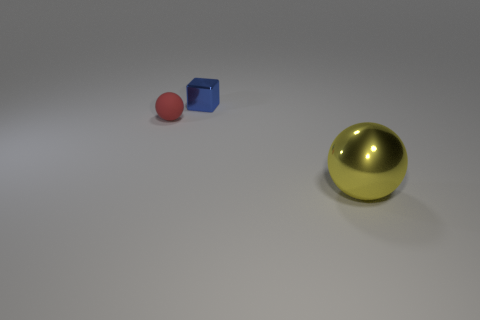Are there the same number of yellow spheres on the left side of the big object and blue metallic cubes?
Your answer should be compact. No. What number of spheres are both right of the tiny blue shiny object and to the left of the blue object?
Keep it short and to the point. 0. What is the size of the yellow sphere that is made of the same material as the blue cube?
Keep it short and to the point. Large. How many blue metal things have the same shape as the tiny red thing?
Your answer should be very brief. 0. Are there more metallic things that are in front of the matte sphere than big cyan blocks?
Make the answer very short. Yes. There is a object that is both on the right side of the red rubber thing and in front of the small metal block; what shape is it?
Offer a terse response. Sphere. Is the red rubber ball the same size as the blue metal block?
Keep it short and to the point. Yes. There is a tiny shiny block; what number of small red objects are to the left of it?
Make the answer very short. 1. Are there the same number of blue objects behind the block and tiny blocks that are on the right side of the tiny red ball?
Give a very brief answer. No. There is a thing in front of the red ball; does it have the same shape as the small metallic thing?
Keep it short and to the point. No. 